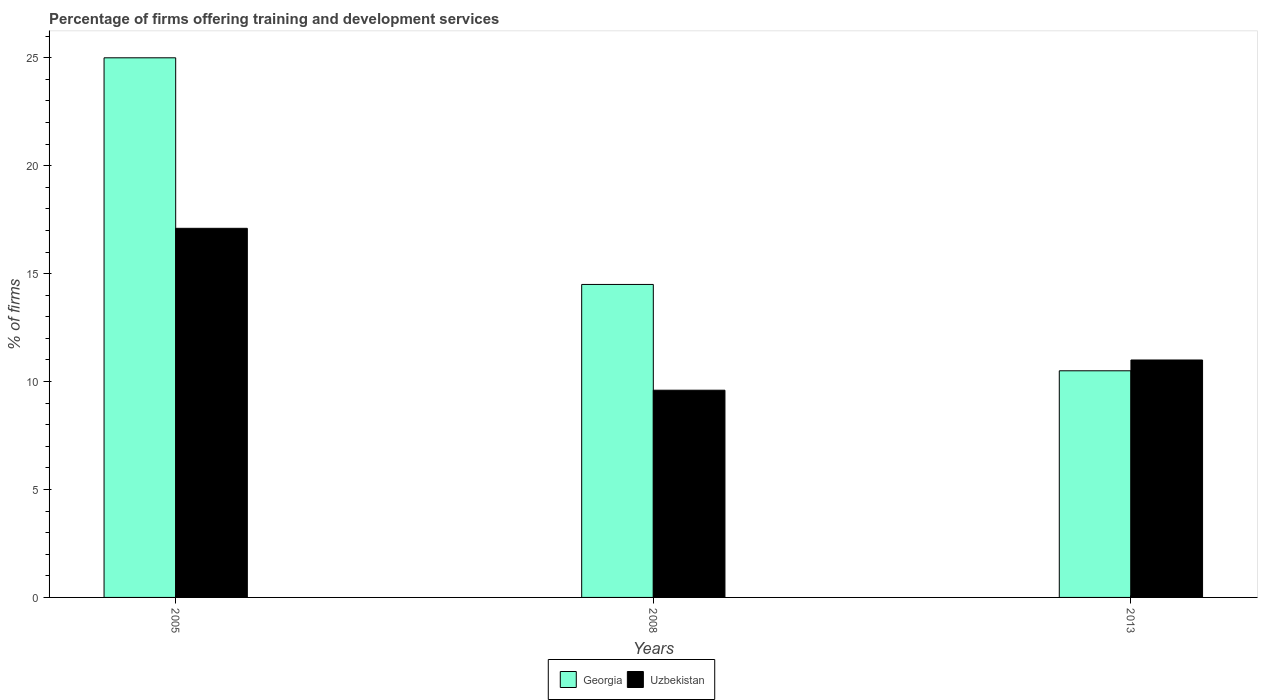How many different coloured bars are there?
Your answer should be very brief. 2. What is the percentage of firms offering training and development in Georgia in 2008?
Your response must be concise. 14.5. Across all years, what is the maximum percentage of firms offering training and development in Uzbekistan?
Your answer should be very brief. 17.1. Across all years, what is the minimum percentage of firms offering training and development in Uzbekistan?
Keep it short and to the point. 9.6. In which year was the percentage of firms offering training and development in Georgia maximum?
Provide a short and direct response. 2005. What is the total percentage of firms offering training and development in Uzbekistan in the graph?
Your answer should be very brief. 37.7. What is the difference between the percentage of firms offering training and development in Uzbekistan in 2005 and that in 2008?
Your answer should be compact. 7.5. What is the difference between the percentage of firms offering training and development in Georgia in 2005 and the percentage of firms offering training and development in Uzbekistan in 2013?
Offer a very short reply. 14. What is the average percentage of firms offering training and development in Uzbekistan per year?
Your answer should be very brief. 12.57. In the year 2005, what is the difference between the percentage of firms offering training and development in Georgia and percentage of firms offering training and development in Uzbekistan?
Offer a terse response. 7.9. In how many years, is the percentage of firms offering training and development in Uzbekistan greater than 16 %?
Provide a short and direct response. 1. What is the ratio of the percentage of firms offering training and development in Uzbekistan in 2008 to that in 2013?
Your answer should be very brief. 0.87. Is the percentage of firms offering training and development in Georgia in 2005 less than that in 2008?
Offer a terse response. No. Is the difference between the percentage of firms offering training and development in Georgia in 2005 and 2013 greater than the difference between the percentage of firms offering training and development in Uzbekistan in 2005 and 2013?
Your answer should be compact. Yes. What is the difference between the highest and the second highest percentage of firms offering training and development in Uzbekistan?
Keep it short and to the point. 6.1. In how many years, is the percentage of firms offering training and development in Georgia greater than the average percentage of firms offering training and development in Georgia taken over all years?
Offer a very short reply. 1. Is the sum of the percentage of firms offering training and development in Uzbekistan in 2008 and 2013 greater than the maximum percentage of firms offering training and development in Georgia across all years?
Make the answer very short. No. What does the 2nd bar from the left in 2005 represents?
Offer a terse response. Uzbekistan. What does the 1st bar from the right in 2013 represents?
Offer a terse response. Uzbekistan. Are all the bars in the graph horizontal?
Keep it short and to the point. No. How many years are there in the graph?
Provide a short and direct response. 3. Are the values on the major ticks of Y-axis written in scientific E-notation?
Make the answer very short. No. Does the graph contain any zero values?
Offer a terse response. No. How are the legend labels stacked?
Give a very brief answer. Horizontal. What is the title of the graph?
Provide a short and direct response. Percentage of firms offering training and development services. What is the label or title of the X-axis?
Your answer should be very brief. Years. What is the label or title of the Y-axis?
Provide a short and direct response. % of firms. What is the % of firms in Georgia in 2005?
Give a very brief answer. 25. What is the % of firms in Uzbekistan in 2008?
Offer a terse response. 9.6. What is the % of firms of Georgia in 2013?
Your response must be concise. 10.5. Across all years, what is the minimum % of firms in Uzbekistan?
Offer a terse response. 9.6. What is the total % of firms in Georgia in the graph?
Provide a succinct answer. 50. What is the total % of firms of Uzbekistan in the graph?
Your answer should be very brief. 37.7. What is the average % of firms of Georgia per year?
Give a very brief answer. 16.67. What is the average % of firms in Uzbekistan per year?
Give a very brief answer. 12.57. In the year 2008, what is the difference between the % of firms in Georgia and % of firms in Uzbekistan?
Provide a short and direct response. 4.9. In the year 2013, what is the difference between the % of firms in Georgia and % of firms in Uzbekistan?
Ensure brevity in your answer.  -0.5. What is the ratio of the % of firms of Georgia in 2005 to that in 2008?
Provide a short and direct response. 1.72. What is the ratio of the % of firms in Uzbekistan in 2005 to that in 2008?
Your answer should be compact. 1.78. What is the ratio of the % of firms of Georgia in 2005 to that in 2013?
Offer a very short reply. 2.38. What is the ratio of the % of firms in Uzbekistan in 2005 to that in 2013?
Offer a terse response. 1.55. What is the ratio of the % of firms in Georgia in 2008 to that in 2013?
Provide a short and direct response. 1.38. What is the ratio of the % of firms of Uzbekistan in 2008 to that in 2013?
Make the answer very short. 0.87. What is the difference between the highest and the lowest % of firms of Georgia?
Provide a short and direct response. 14.5. 